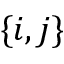Convert formula to latex. <formula><loc_0><loc_0><loc_500><loc_500>\{ i , j \}</formula> 